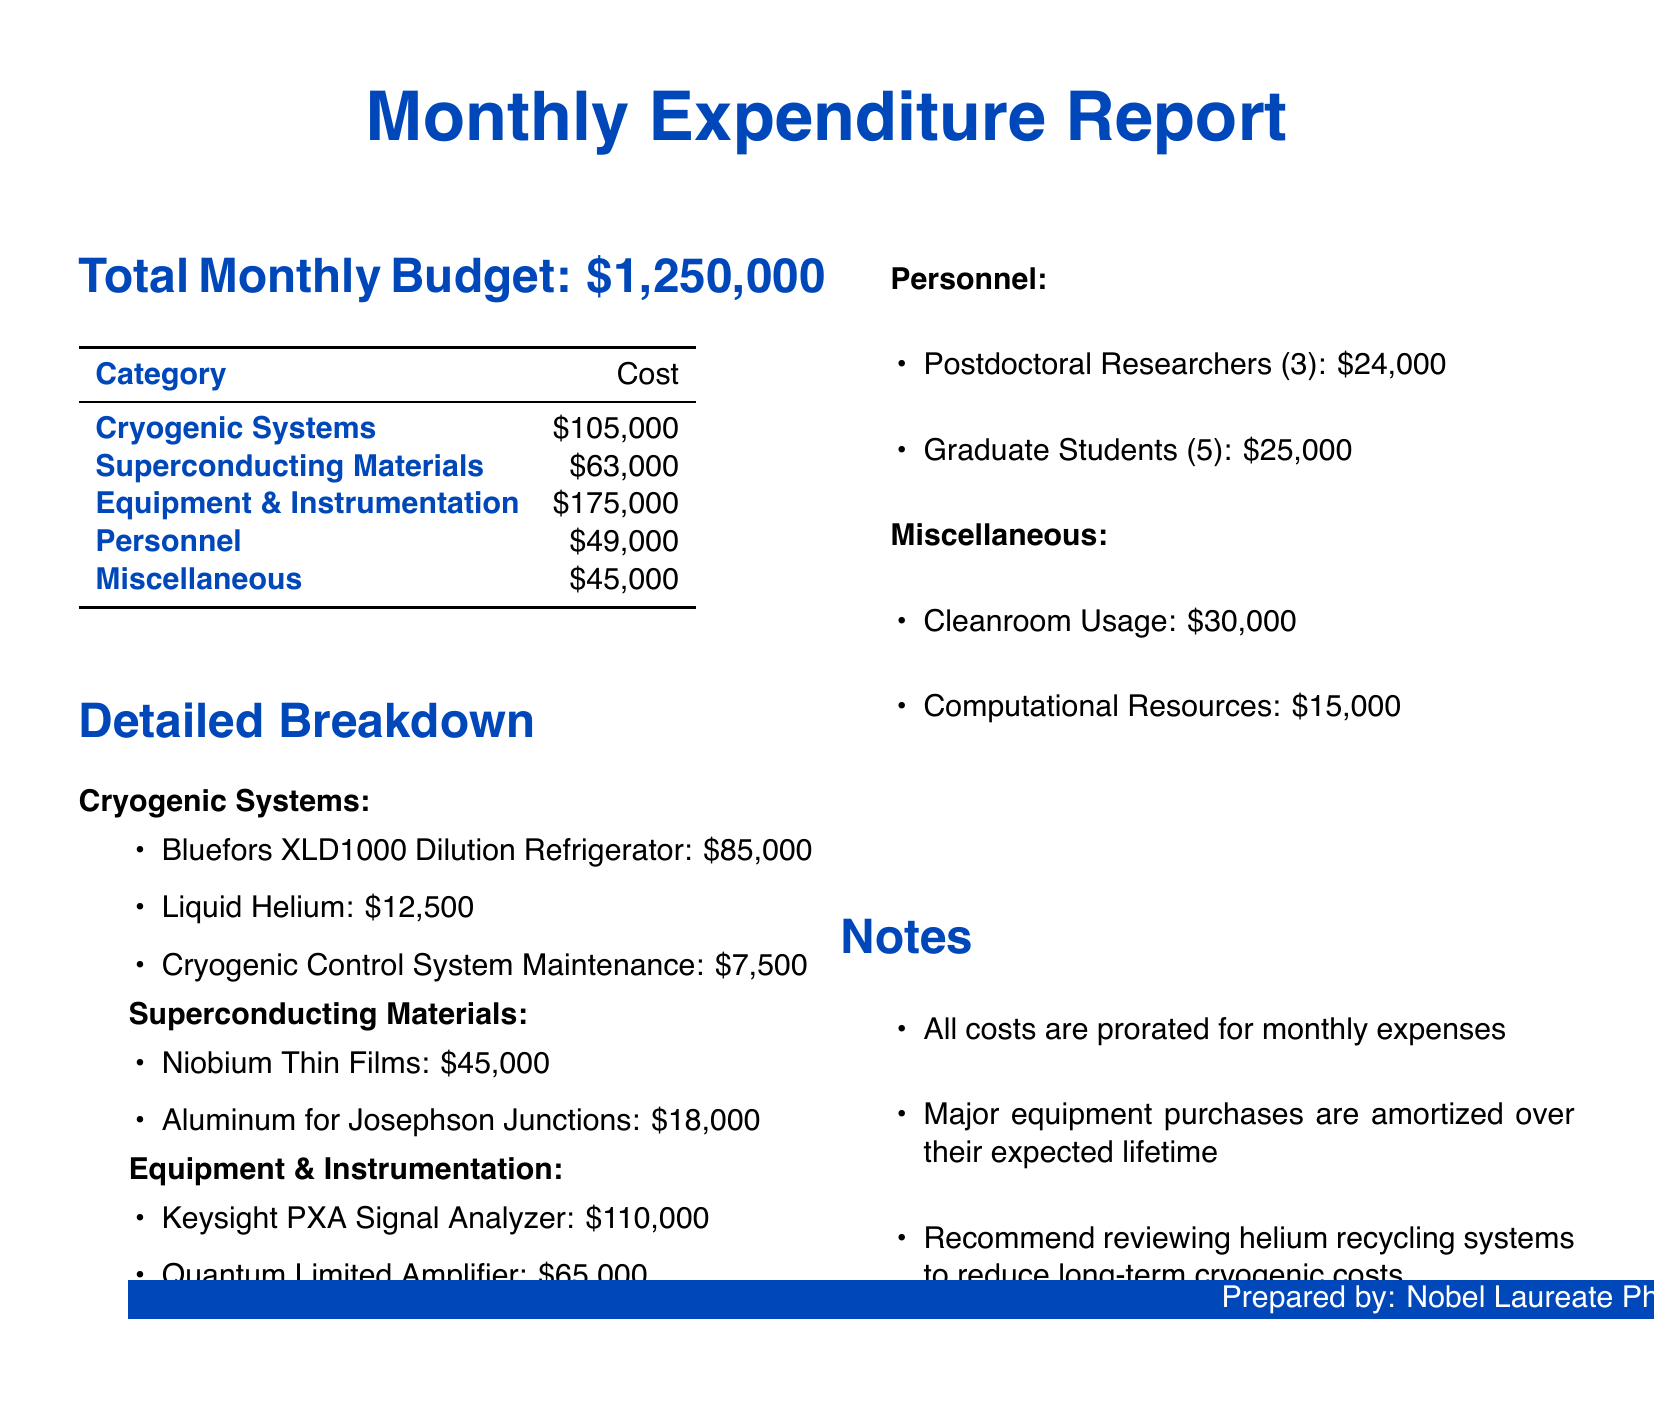What is the total monthly budget? The total monthly budget is stated at the beginning of the report.
Answer: $1,250,000 How much is spent on cryogenic systems? The document specifies the cost allocated to cryogenic systems under the total monthly budget.
Answer: $105,000 What is the cost of the Bluefors XLD1000 Dilution Refrigerator? The detailed breakdown provides the cost of this specific cryogenic system item.
Answer: $85,000 How many graduate students are accounted for in the personnel costs? The personnel section lists the number of graduate students included in the budget.
Answer: 5 What is the total cost of superconducting materials? The document summarizes the costs associated with superconducting materials in the total monthly budget.
Answer: $63,000 What recommendation is made regarding cryogenic costs? The notes section highlights a proposed method to reduce long-term costs related to cryogenics.
Answer: Reviewing helium recycling systems How much is allocated for cleanroom usage? The miscellaneous section mentions the allocated amount for cleanroom usage directly.
Answer: $30,000 What is the combined cost of the Keysight PXA Signal Analyzer and Quantum Limited Amplifier? The equipment section lists the prices of these two items, which can be added together for the total.
Answer: $175,000 What type of report is this? The title of the document clearly indicates the nature of the content presented.
Answer: Monthly Expenditure Report 